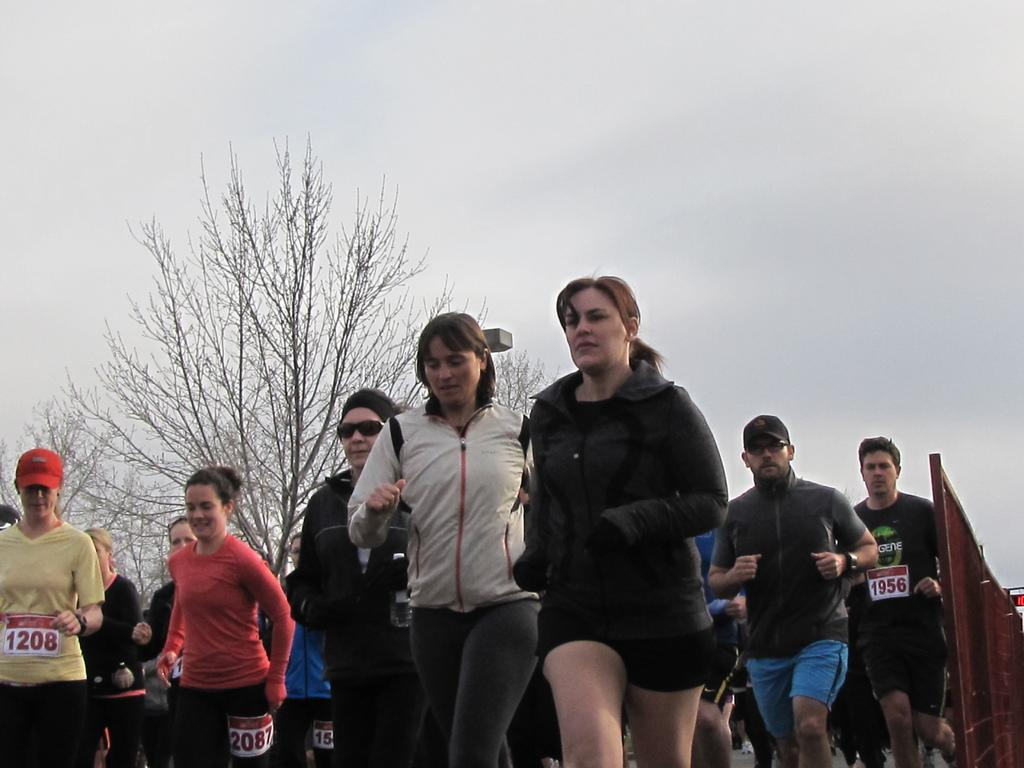What is the woman in the image doing? The woman is running in the image. What is the woman wearing while running? The woman is wearing a black dress. Are there other people running in the image? Yes, there are other persons running in the image. What can be seen on the left side of the image? There is a tree on the left side of the image. How would you describe the weather in the image? The sky is cloudy in the image, suggesting a potentially overcast or rainy day. What is the income of the woman running in the image? There is no information about the woman's income in the image. Can you see a cushion on the ground in the image? There is no cushion visible in the image. 